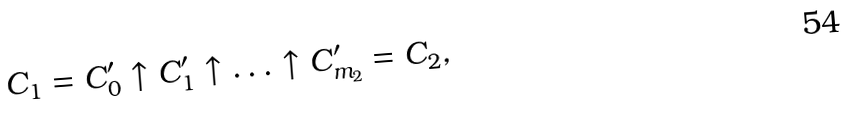<formula> <loc_0><loc_0><loc_500><loc_500>C _ { 1 } = C ^ { \prime } _ { 0 } \uparrow C ^ { \prime } _ { 1 } \uparrow \dots \uparrow C ^ { \prime } _ { m _ { 2 } } = C _ { 2 } ,</formula> 